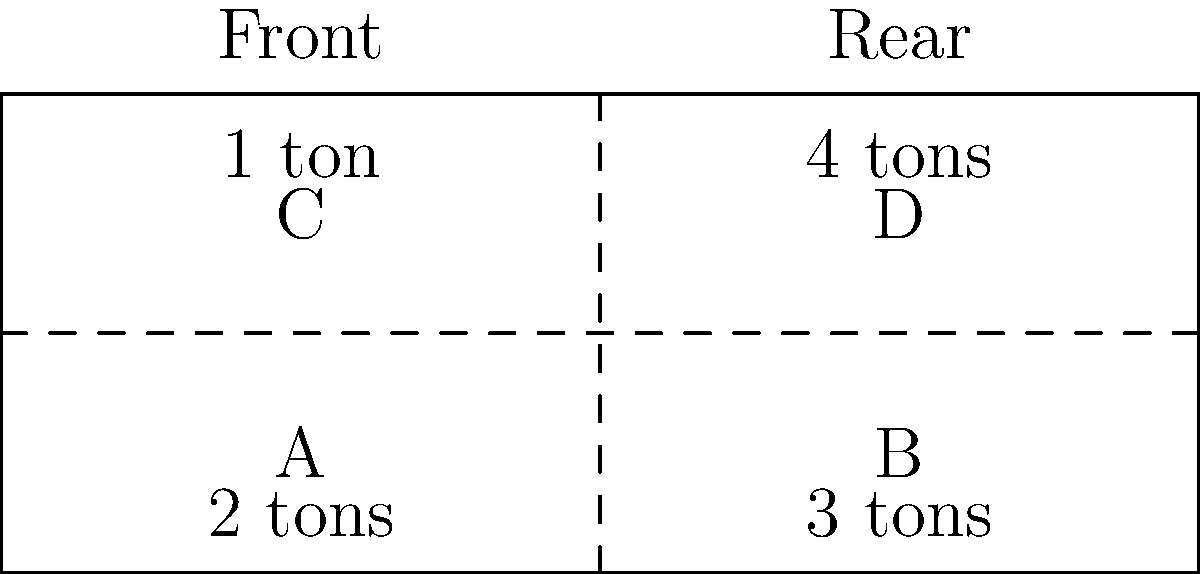You're loading a truck for a long-distance delivery. The diagram shows the truck bed divided into four sections (A, B, C, D) with their respective cargo weights. What is the difference in total weight between the front and rear halves of the truck, and which half is heavier? To solve this problem, we need to follow these steps:

1. Calculate the total weight in the front half:
   Section A: 2 tons
   Section C: 1 ton
   Front total = 2 + 1 = 3 tons

2. Calculate the total weight in the rear half:
   Section B: 3 tons
   Section D: 4 tons
   Rear total = 3 + 4 = 7 tons

3. Calculate the difference between rear and front:
   Difference = Rear total - Front total
               = 7 tons - 3 tons
               = 4 tons

4. Determine which half is heavier:
   The rear half (7 tons) is heavier than the front half (3 tons).

Therefore, the difference in total weight between the front and rear halves is 4 tons, and the rear half is heavier.
Answer: 4 tons, rear half 